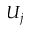<formula> <loc_0><loc_0><loc_500><loc_500>U _ { j }</formula> 